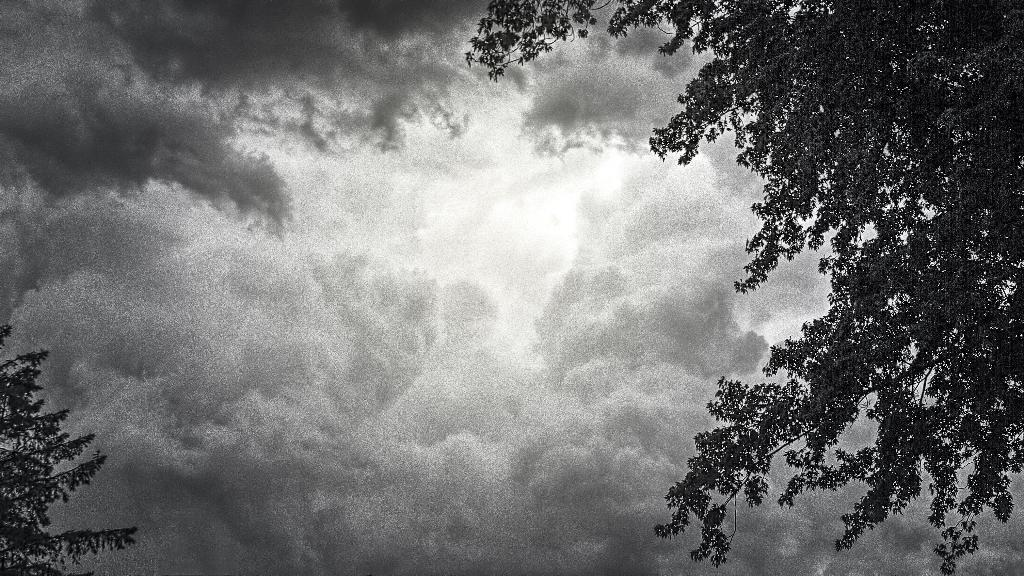What is visible at the top of the image? The sky is visible in the image. What can be seen in the sky in the image? Clouds are present in the image. What type of vegetation is on the right side of the image? There are trees on the right side of the image. What type of vegetation is on the left side of the image? There are trees on the left side of the image. What type of grain is growing in the heart of the image? There is no grain or heart present in the image; it features the sky and trees. 